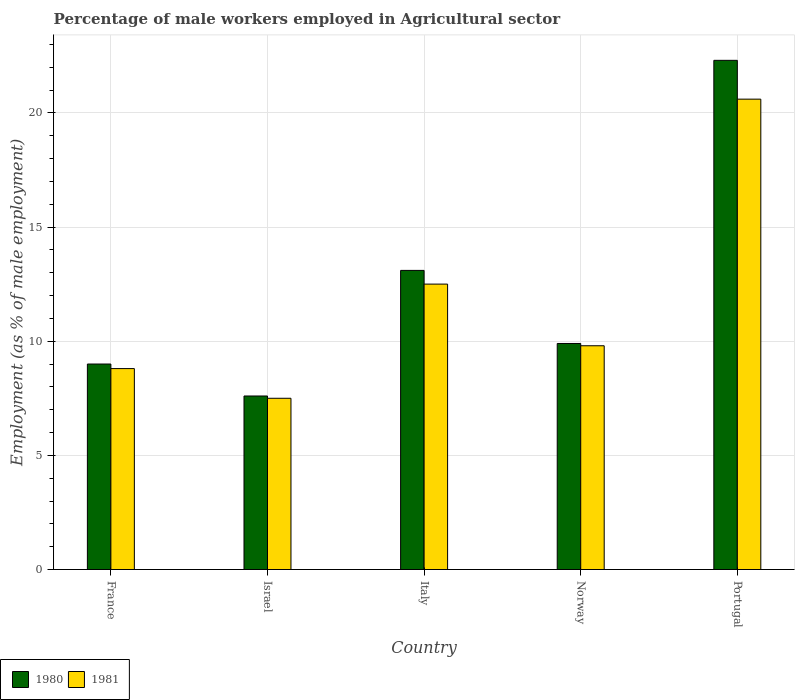Are the number of bars per tick equal to the number of legend labels?
Offer a very short reply. Yes. Are the number of bars on each tick of the X-axis equal?
Your answer should be very brief. Yes. How many bars are there on the 4th tick from the left?
Ensure brevity in your answer.  2. What is the label of the 3rd group of bars from the left?
Your answer should be compact. Italy. What is the percentage of male workers employed in Agricultural sector in 1980 in France?
Make the answer very short. 9. Across all countries, what is the maximum percentage of male workers employed in Agricultural sector in 1980?
Your response must be concise. 22.3. In which country was the percentage of male workers employed in Agricultural sector in 1981 maximum?
Provide a succinct answer. Portugal. In which country was the percentage of male workers employed in Agricultural sector in 1981 minimum?
Your answer should be very brief. Israel. What is the total percentage of male workers employed in Agricultural sector in 1980 in the graph?
Your answer should be compact. 61.9. What is the difference between the percentage of male workers employed in Agricultural sector in 1981 in Israel and that in Portugal?
Your answer should be compact. -13.1. What is the difference between the percentage of male workers employed in Agricultural sector in 1980 in Portugal and the percentage of male workers employed in Agricultural sector in 1981 in Norway?
Ensure brevity in your answer.  12.5. What is the average percentage of male workers employed in Agricultural sector in 1980 per country?
Give a very brief answer. 12.38. What is the difference between the percentage of male workers employed in Agricultural sector of/in 1981 and percentage of male workers employed in Agricultural sector of/in 1980 in Norway?
Offer a terse response. -0.1. What is the ratio of the percentage of male workers employed in Agricultural sector in 1981 in Israel to that in Portugal?
Keep it short and to the point. 0.36. What is the difference between the highest and the second highest percentage of male workers employed in Agricultural sector in 1981?
Your response must be concise. -10.8. What is the difference between the highest and the lowest percentage of male workers employed in Agricultural sector in 1981?
Offer a terse response. 13.1. Is the sum of the percentage of male workers employed in Agricultural sector in 1981 in Norway and Portugal greater than the maximum percentage of male workers employed in Agricultural sector in 1980 across all countries?
Make the answer very short. Yes. How many countries are there in the graph?
Keep it short and to the point. 5. Does the graph contain any zero values?
Your response must be concise. No. Does the graph contain grids?
Give a very brief answer. Yes. How many legend labels are there?
Keep it short and to the point. 2. How are the legend labels stacked?
Your response must be concise. Horizontal. What is the title of the graph?
Offer a terse response. Percentage of male workers employed in Agricultural sector. What is the label or title of the X-axis?
Offer a very short reply. Country. What is the label or title of the Y-axis?
Keep it short and to the point. Employment (as % of male employment). What is the Employment (as % of male employment) in 1981 in France?
Ensure brevity in your answer.  8.8. What is the Employment (as % of male employment) in 1980 in Israel?
Give a very brief answer. 7.6. What is the Employment (as % of male employment) of 1981 in Israel?
Offer a terse response. 7.5. What is the Employment (as % of male employment) in 1980 in Italy?
Your answer should be compact. 13.1. What is the Employment (as % of male employment) in 1980 in Norway?
Give a very brief answer. 9.9. What is the Employment (as % of male employment) in 1981 in Norway?
Offer a very short reply. 9.8. What is the Employment (as % of male employment) of 1980 in Portugal?
Make the answer very short. 22.3. What is the Employment (as % of male employment) of 1981 in Portugal?
Provide a short and direct response. 20.6. Across all countries, what is the maximum Employment (as % of male employment) of 1980?
Offer a terse response. 22.3. Across all countries, what is the maximum Employment (as % of male employment) of 1981?
Your answer should be compact. 20.6. Across all countries, what is the minimum Employment (as % of male employment) in 1980?
Give a very brief answer. 7.6. What is the total Employment (as % of male employment) in 1980 in the graph?
Keep it short and to the point. 61.9. What is the total Employment (as % of male employment) in 1981 in the graph?
Your response must be concise. 59.2. What is the difference between the Employment (as % of male employment) of 1980 in France and that in Israel?
Your response must be concise. 1.4. What is the difference between the Employment (as % of male employment) of 1981 in France and that in Israel?
Your answer should be very brief. 1.3. What is the difference between the Employment (as % of male employment) of 1980 in France and that in Norway?
Offer a terse response. -0.9. What is the difference between the Employment (as % of male employment) of 1980 in France and that in Portugal?
Offer a terse response. -13.3. What is the difference between the Employment (as % of male employment) of 1981 in France and that in Portugal?
Your answer should be very brief. -11.8. What is the difference between the Employment (as % of male employment) in 1980 in Israel and that in Italy?
Provide a short and direct response. -5.5. What is the difference between the Employment (as % of male employment) in 1980 in Israel and that in Norway?
Make the answer very short. -2.3. What is the difference between the Employment (as % of male employment) of 1981 in Israel and that in Norway?
Your response must be concise. -2.3. What is the difference between the Employment (as % of male employment) of 1980 in Israel and that in Portugal?
Make the answer very short. -14.7. What is the difference between the Employment (as % of male employment) of 1981 in Israel and that in Portugal?
Your answer should be compact. -13.1. What is the difference between the Employment (as % of male employment) in 1980 in Italy and that in Portugal?
Keep it short and to the point. -9.2. What is the difference between the Employment (as % of male employment) of 1980 in France and the Employment (as % of male employment) of 1981 in Israel?
Offer a terse response. 1.5. What is the difference between the Employment (as % of male employment) of 1980 in France and the Employment (as % of male employment) of 1981 in Norway?
Ensure brevity in your answer.  -0.8. What is the difference between the Employment (as % of male employment) in 1980 in France and the Employment (as % of male employment) in 1981 in Portugal?
Provide a short and direct response. -11.6. What is the difference between the Employment (as % of male employment) of 1980 in Israel and the Employment (as % of male employment) of 1981 in Italy?
Provide a succinct answer. -4.9. What is the difference between the Employment (as % of male employment) of 1980 in Israel and the Employment (as % of male employment) of 1981 in Portugal?
Your answer should be compact. -13. What is the difference between the Employment (as % of male employment) in 1980 in Italy and the Employment (as % of male employment) in 1981 in Norway?
Your response must be concise. 3.3. What is the difference between the Employment (as % of male employment) of 1980 in Italy and the Employment (as % of male employment) of 1981 in Portugal?
Your answer should be compact. -7.5. What is the average Employment (as % of male employment) in 1980 per country?
Your response must be concise. 12.38. What is the average Employment (as % of male employment) of 1981 per country?
Your answer should be compact. 11.84. What is the difference between the Employment (as % of male employment) of 1980 and Employment (as % of male employment) of 1981 in France?
Your answer should be compact. 0.2. What is the difference between the Employment (as % of male employment) in 1980 and Employment (as % of male employment) in 1981 in Italy?
Your response must be concise. 0.6. What is the difference between the Employment (as % of male employment) of 1980 and Employment (as % of male employment) of 1981 in Norway?
Ensure brevity in your answer.  0.1. What is the difference between the Employment (as % of male employment) of 1980 and Employment (as % of male employment) of 1981 in Portugal?
Offer a terse response. 1.7. What is the ratio of the Employment (as % of male employment) in 1980 in France to that in Israel?
Your response must be concise. 1.18. What is the ratio of the Employment (as % of male employment) of 1981 in France to that in Israel?
Keep it short and to the point. 1.17. What is the ratio of the Employment (as % of male employment) of 1980 in France to that in Italy?
Your response must be concise. 0.69. What is the ratio of the Employment (as % of male employment) of 1981 in France to that in Italy?
Your answer should be very brief. 0.7. What is the ratio of the Employment (as % of male employment) in 1981 in France to that in Norway?
Provide a short and direct response. 0.9. What is the ratio of the Employment (as % of male employment) of 1980 in France to that in Portugal?
Give a very brief answer. 0.4. What is the ratio of the Employment (as % of male employment) of 1981 in France to that in Portugal?
Ensure brevity in your answer.  0.43. What is the ratio of the Employment (as % of male employment) of 1980 in Israel to that in Italy?
Provide a short and direct response. 0.58. What is the ratio of the Employment (as % of male employment) of 1981 in Israel to that in Italy?
Ensure brevity in your answer.  0.6. What is the ratio of the Employment (as % of male employment) in 1980 in Israel to that in Norway?
Keep it short and to the point. 0.77. What is the ratio of the Employment (as % of male employment) in 1981 in Israel to that in Norway?
Ensure brevity in your answer.  0.77. What is the ratio of the Employment (as % of male employment) of 1980 in Israel to that in Portugal?
Provide a short and direct response. 0.34. What is the ratio of the Employment (as % of male employment) of 1981 in Israel to that in Portugal?
Make the answer very short. 0.36. What is the ratio of the Employment (as % of male employment) in 1980 in Italy to that in Norway?
Your answer should be compact. 1.32. What is the ratio of the Employment (as % of male employment) of 1981 in Italy to that in Norway?
Ensure brevity in your answer.  1.28. What is the ratio of the Employment (as % of male employment) of 1980 in Italy to that in Portugal?
Provide a succinct answer. 0.59. What is the ratio of the Employment (as % of male employment) of 1981 in Italy to that in Portugal?
Make the answer very short. 0.61. What is the ratio of the Employment (as % of male employment) of 1980 in Norway to that in Portugal?
Provide a succinct answer. 0.44. What is the ratio of the Employment (as % of male employment) in 1981 in Norway to that in Portugal?
Ensure brevity in your answer.  0.48. What is the difference between the highest and the lowest Employment (as % of male employment) of 1981?
Give a very brief answer. 13.1. 